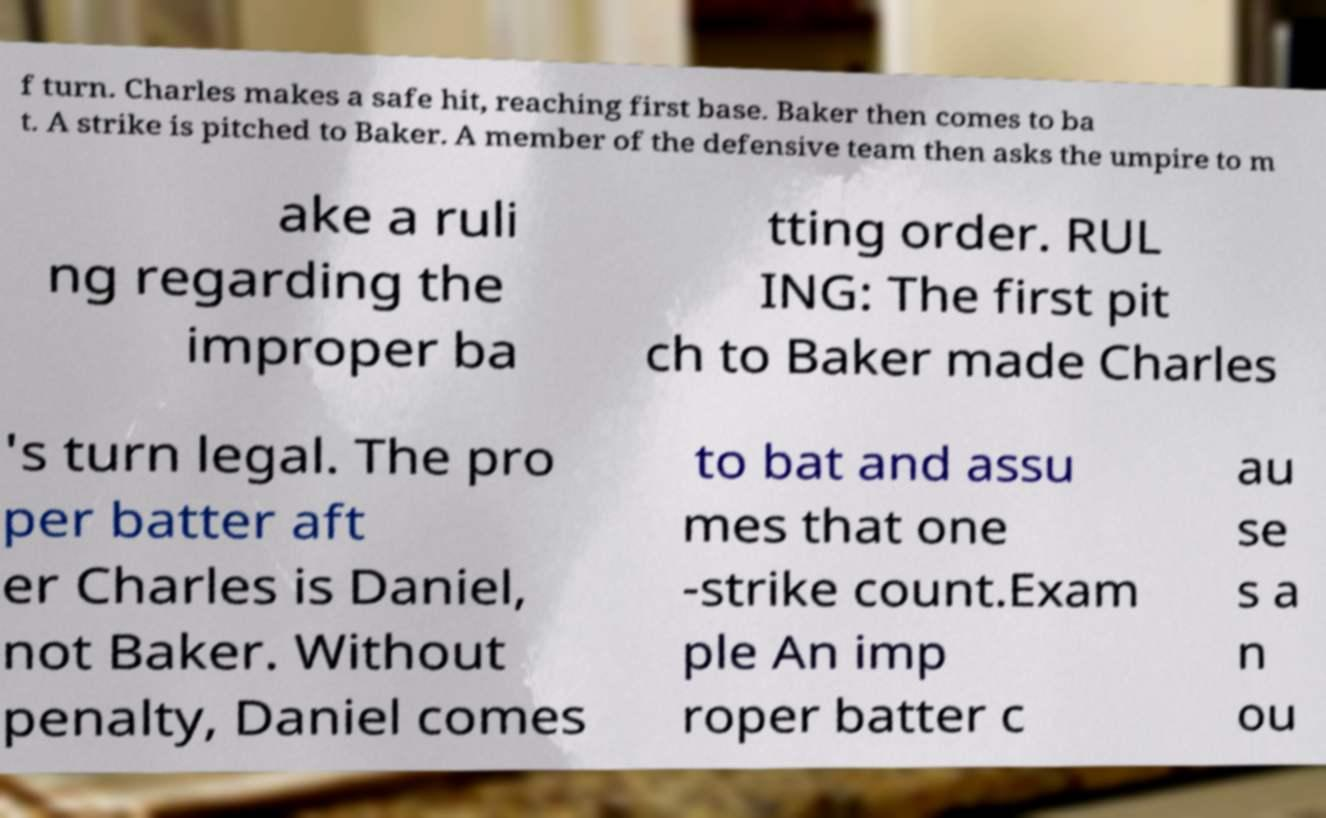Could you extract and type out the text from this image? f turn. Charles makes a safe hit, reaching first base. Baker then comes to ba t. A strike is pitched to Baker. A member of the defensive team then asks the umpire to m ake a ruli ng regarding the improper ba tting order. RUL ING: The first pit ch to Baker made Charles 's turn legal. The pro per batter aft er Charles is Daniel, not Baker. Without penalty, Daniel comes to bat and assu mes that one -strike count.Exam ple An imp roper batter c au se s a n ou 